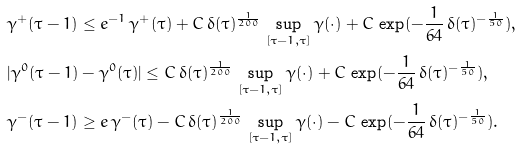<formula> <loc_0><loc_0><loc_500><loc_500>& \gamma ^ { + } ( \tau - 1 ) \leq e ^ { - 1 } \, \gamma ^ { + } ( \tau ) + C \, \delta ( \tau ) ^ { \frac { 1 } { 2 0 0 } } \, \sup _ { [ \tau - 1 , \tau ] } \gamma ( \cdot ) + C \, \exp ( - \frac { 1 } { 6 4 } \, \delta ( \tau ) ^ { - \frac { 1 } { 5 0 } } ) , \\ & | \gamma ^ { 0 } ( \tau - 1 ) - \gamma ^ { 0 } ( \tau ) | \leq C \, \delta ( \tau ) ^ { \frac { 1 } { 2 0 0 } } \, \sup _ { [ \tau - 1 , \tau ] } \gamma ( \cdot ) + C \, \exp ( - \frac { 1 } { 6 4 } \, \delta ( \tau ) ^ { - \frac { 1 } { 5 0 } } ) , \\ & \gamma ^ { - } ( \tau - 1 ) \geq e \, \gamma ^ { - } ( \tau ) - C \, \delta ( \tau ) ^ { \frac { 1 } { 2 0 0 } } \, \sup _ { [ \tau - 1 , \tau ] } \gamma ( \cdot ) - C \, \exp ( - \frac { 1 } { 6 4 } \, \delta ( \tau ) ^ { - \frac { 1 } { 5 0 } } ) .</formula> 